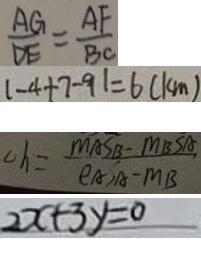<formula> <loc_0><loc_0><loc_500><loc_500>\frac { A G } { D E } = \frac { A F } { B C } 
 \vert - 4 + 7 - 9 \vert = 6 ( k m ) 
 c h = \frac { m A S B - M B S A } { \rho A _ { 1 } A - M B } 
 2 x + 3 y = 0</formula> 